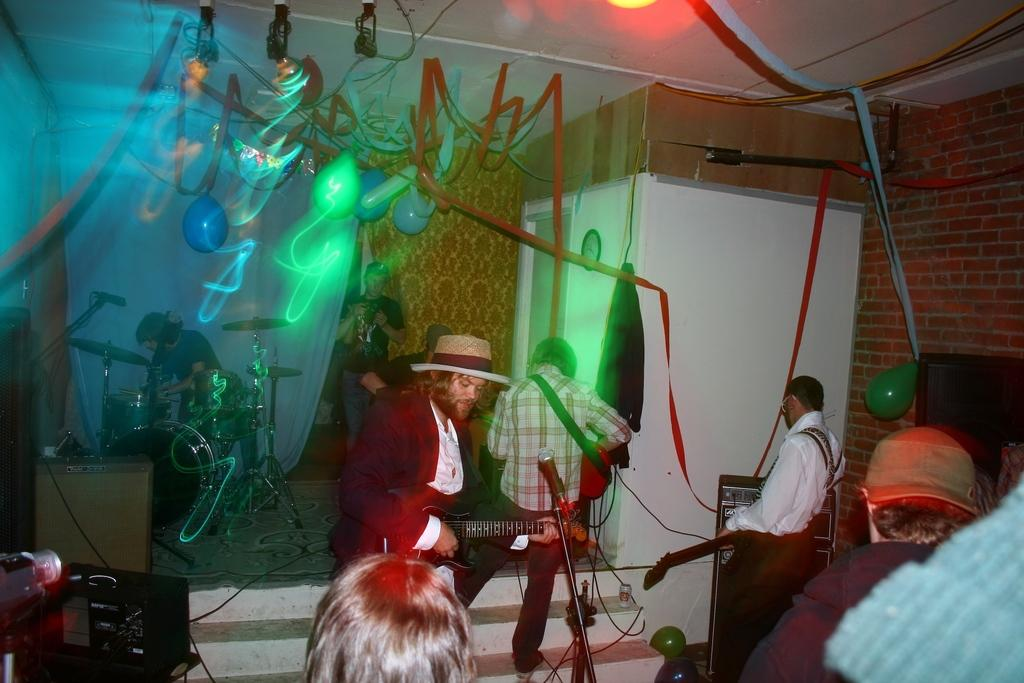What are the people in the room doing? The people in the room are playing musical instruments. What piece of furniture can be seen in the room? There is a desk in the room. What is used for amplifying sound in the room? There are speakers in the room. What decorative items are present in the room? There are balloons and ribbons tied to the roof in the room. Can you hear the thunder in the room? There is no mention of thunder in the image, so it cannot be heard in the room. 